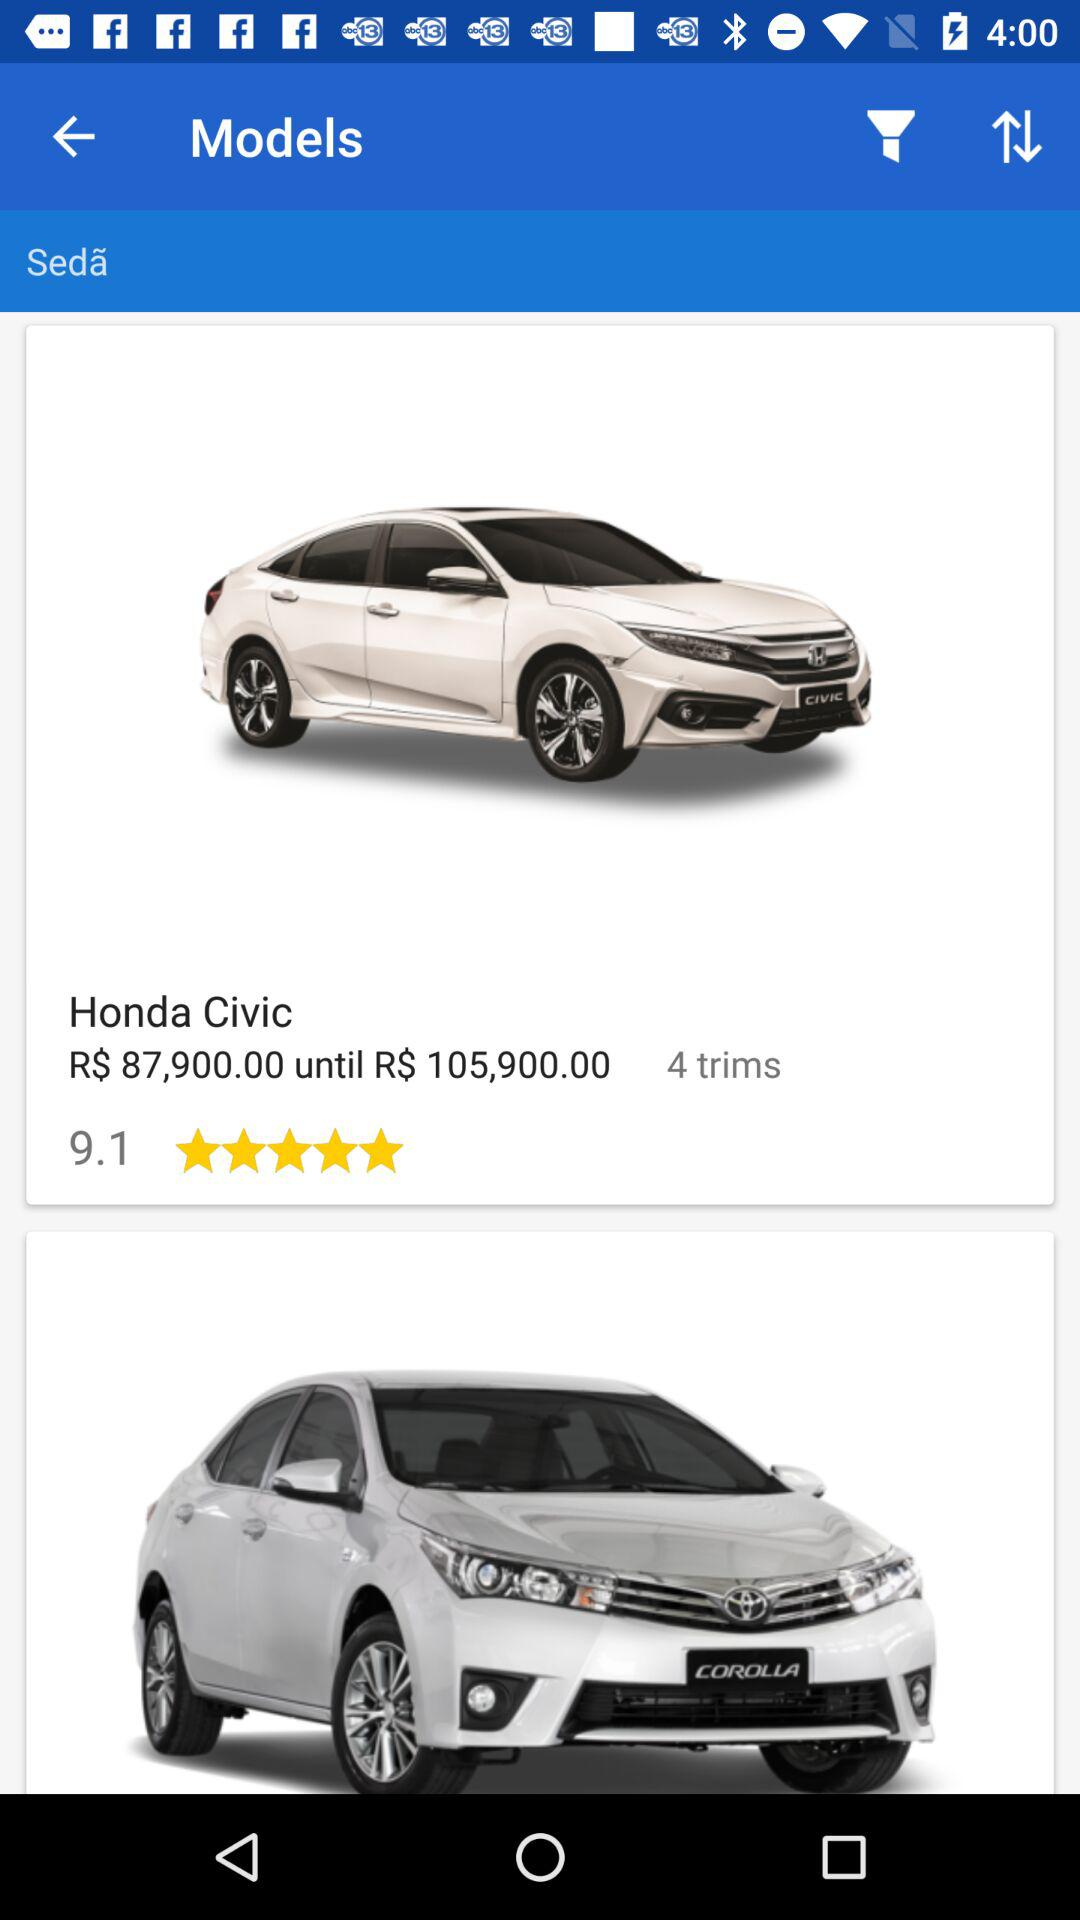What is the model name of car? The model of the car is "Sedã". 